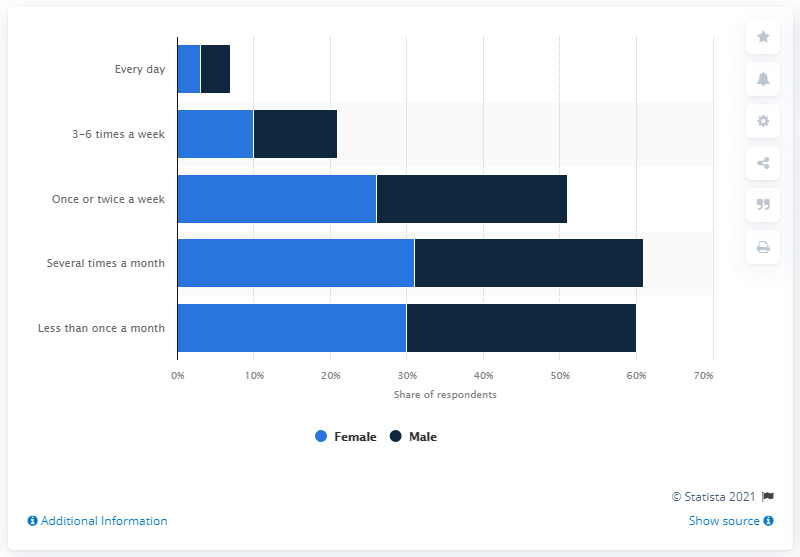List a handful of essential elements in this visual. During the COVID-19 pandemic, a significant percentage of males reported purchasing items online at least several times a month, with 30% of males indicating they made online purchases this frequently. During the COVID-19 pandemic, a survey found that 31% of females reported purchasing items online at least several times a month. 